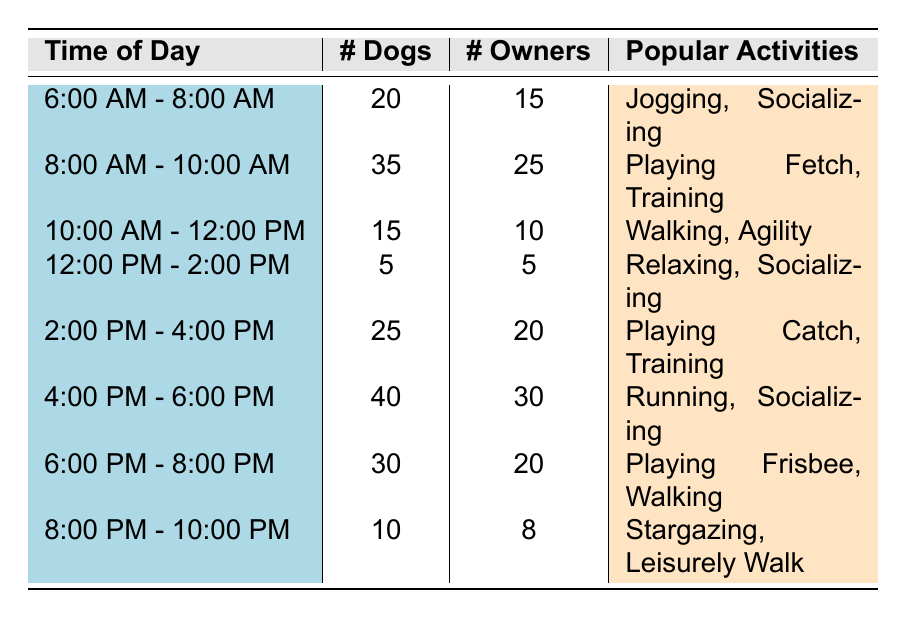What time of day has the highest number of dogs? By examining the table, I can see that the highest number of dogs is listed under the time slot "4:00 PM - 6:00 PM" with a total of 40 dogs.
Answer: 4:00 PM - 6:00 PM What are the popular activities during the noon hours (12:00 PM - 2:00 PM)? In the row corresponding to "12:00 PM - 2:00 PM," the popular activities listed are "Relaxing" and "Socializing."
Answer: Relaxing, Socializing How many dogs are present from 8:00 AM to 10:00 AM combined with those from 4:00 PM to 6:00 PM? First, I note the number of dogs for the time slots: "8:00 AM - 10:00 AM" has 35 dogs and "4:00 PM - 6:00 PM" has 40 dogs. Adding these gives 35 + 40 = 75 dogs total.
Answer: 75 Is the number of owners greater in the morning hours (6:00 AM - 10:00 AM) compared to the afternoon hours (12:00 PM - 4:00 PM)? The total number of owners from 6:00 AM - 10:00 AM is 15 + 25 = 40. From 12:00 PM - 4:00 PM, it is 5 + 20 = 25. Since 40 is greater than 25, the answer is yes.
Answer: Yes What is the average number of dogs present from 6:00 PM to 10:00 PM? The time slots in this range are "6:00 PM - 8:00 PM" with 30 dogs and "8:00 PM - 10:00 PM" with 10 dogs. To find the average, I sum them up: 30 + 10 = 40, then divide by 2 time slots: 40/2 = 20.
Answer: 20 Are there more owners or dogs present between 10:00 AM and 12:00 PM? During "10:00 AM - 12:00 PM," the statistics show 15 dogs and 10 owners. Since 15 is greater than 10, there are more dogs.
Answer: More dogs How many total owners are in the park from morning (6:00 AM - 12:00 PM)? Summing the owners for the morning hours involves three time slots: "6:00 AM - 8:00 AM" with 15, "8:00 AM - 10:00 AM" with 25, and "10:00 AM - 12:00 PM" with 10. Adding these gives 15 + 25 + 10 = 50 owners in total.
Answer: 50 During which time slot is the participation of owners the lowest? Looking at the number of owners across all time slots, "12:00 PM - 2:00 PM" indicates there are only 5 owners, which is less than any other time slot's owner count.
Answer: 12:00 PM - 2:00 PM 